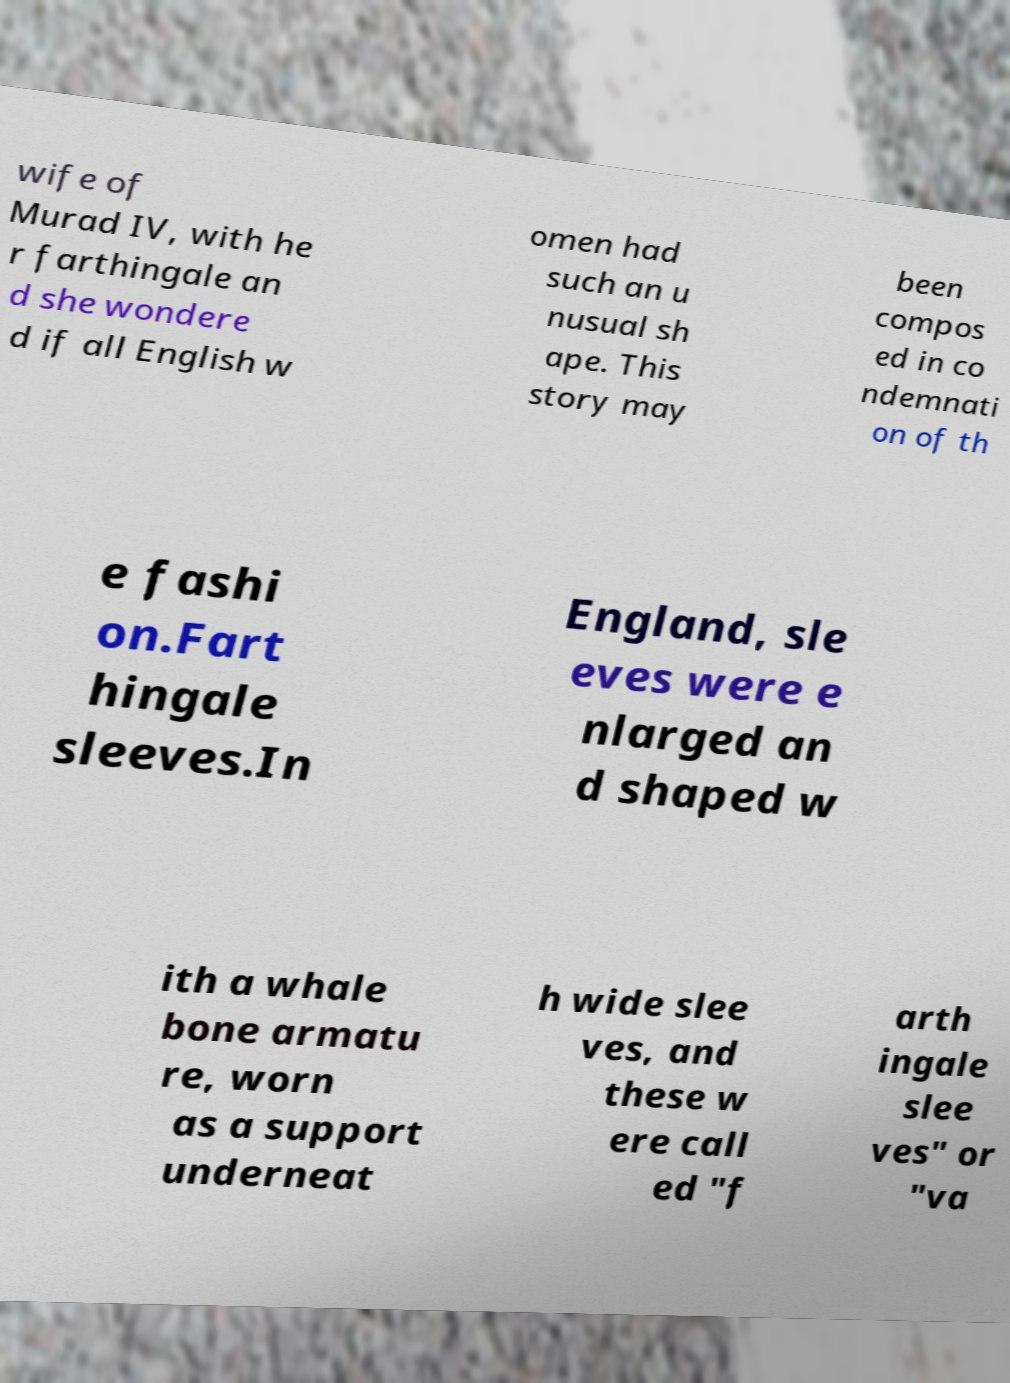I need the written content from this picture converted into text. Can you do that? wife of Murad IV, with he r farthingale an d she wondere d if all English w omen had such an u nusual sh ape. This story may been compos ed in co ndemnati on of th e fashi on.Fart hingale sleeves.In England, sle eves were e nlarged an d shaped w ith a whale bone armatu re, worn as a support underneat h wide slee ves, and these w ere call ed "f arth ingale slee ves" or "va 